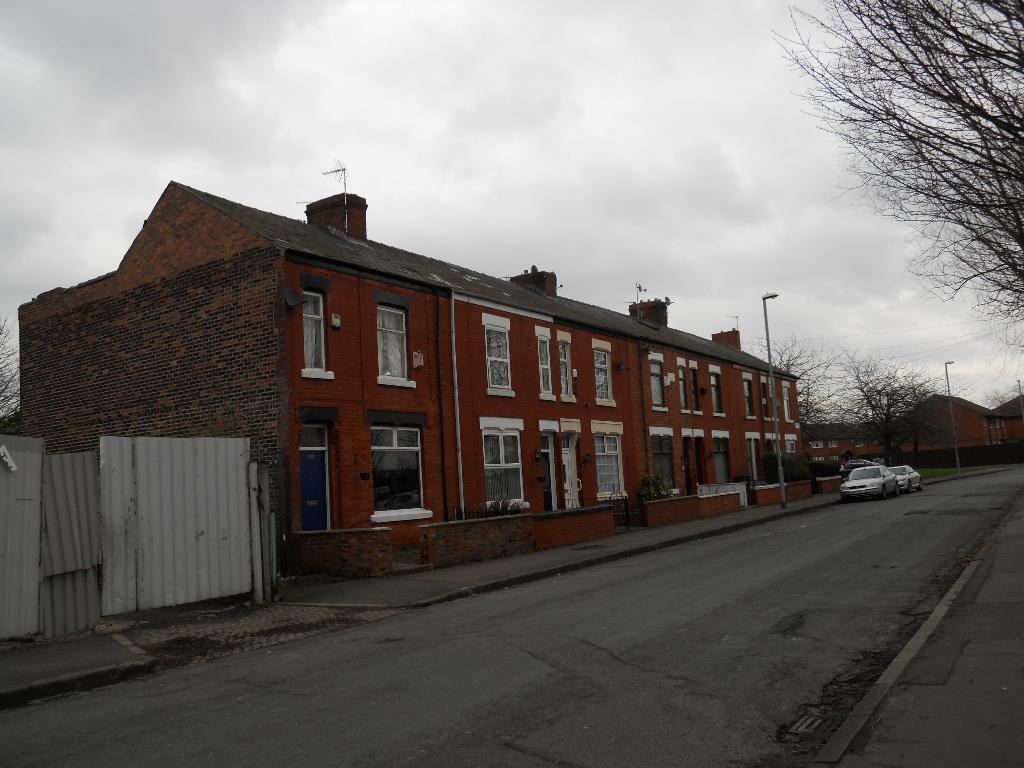What is the weather condition in the image? The sky is cloudy in the image. What type of structures can be seen in the image? There are buildings in the image. What feature is visible on the buildings? Glass windows are visible in the image. What type of vegetation is present in the image? Bare trees are present in the image. What are the light sources in the image? Light poles are visible in the image. What type of transportation is present in the image? Vehicles are present in the image. What type of vegetable is growing on the light poles in the image? There are no vegetables growing on the light poles in the image. How many tickets are visible in the image? There are no tickets present in the image. 